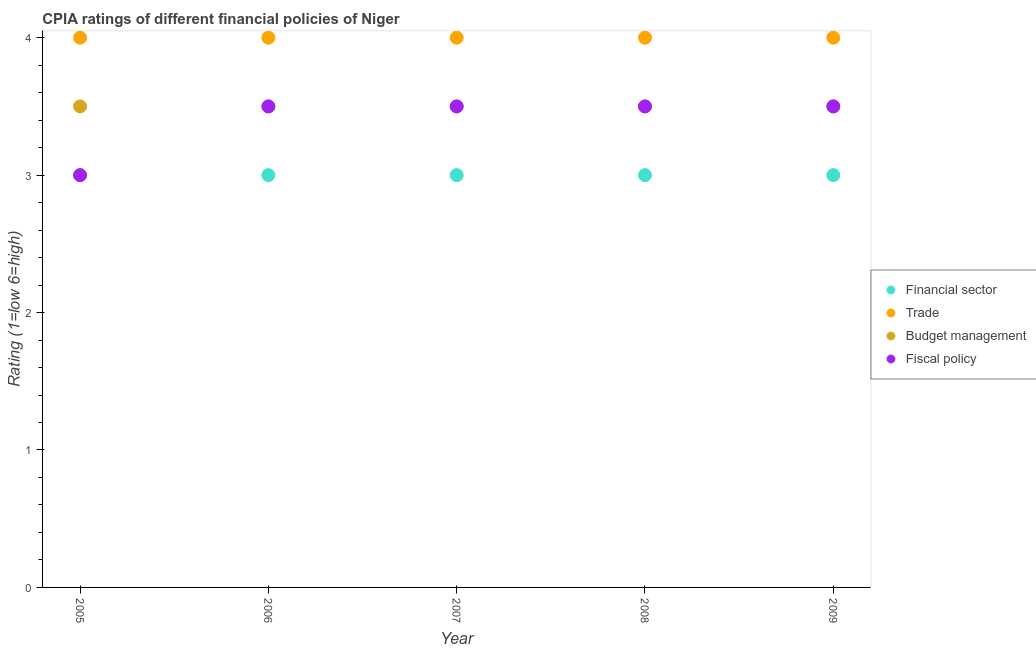Across all years, what is the maximum cpia rating of trade?
Keep it short and to the point. 4. Across all years, what is the minimum cpia rating of fiscal policy?
Your answer should be very brief. 3. What is the total cpia rating of budget management in the graph?
Offer a very short reply. 17.5. Is the cpia rating of fiscal policy in 2006 less than that in 2009?
Your answer should be compact. No. Is the difference between the cpia rating of trade in 2005 and 2006 greater than the difference between the cpia rating of financial sector in 2005 and 2006?
Your answer should be very brief. No. Is the sum of the cpia rating of fiscal policy in 2005 and 2009 greater than the maximum cpia rating of trade across all years?
Your response must be concise. Yes. Is it the case that in every year, the sum of the cpia rating of financial sector and cpia rating of trade is greater than the cpia rating of budget management?
Ensure brevity in your answer.  Yes. Is the cpia rating of trade strictly less than the cpia rating of fiscal policy over the years?
Provide a short and direct response. No. How many dotlines are there?
Your response must be concise. 4. What is the difference between two consecutive major ticks on the Y-axis?
Your response must be concise. 1. Are the values on the major ticks of Y-axis written in scientific E-notation?
Ensure brevity in your answer.  No. Does the graph contain any zero values?
Your answer should be very brief. No. Does the graph contain grids?
Give a very brief answer. No. Where does the legend appear in the graph?
Your answer should be very brief. Center right. How many legend labels are there?
Ensure brevity in your answer.  4. What is the title of the graph?
Your response must be concise. CPIA ratings of different financial policies of Niger. Does "European Union" appear as one of the legend labels in the graph?
Make the answer very short. No. What is the label or title of the X-axis?
Your answer should be compact. Year. What is the label or title of the Y-axis?
Provide a short and direct response. Rating (1=low 6=high). What is the Rating (1=low 6=high) in Trade in 2005?
Give a very brief answer. 4. What is the Rating (1=low 6=high) in Budget management in 2005?
Provide a succinct answer. 3.5. What is the Rating (1=low 6=high) of Fiscal policy in 2005?
Ensure brevity in your answer.  3. What is the Rating (1=low 6=high) of Financial sector in 2006?
Ensure brevity in your answer.  3. What is the Rating (1=low 6=high) in Fiscal policy in 2006?
Your response must be concise. 3.5. What is the Rating (1=low 6=high) in Trade in 2007?
Make the answer very short. 4. What is the Rating (1=low 6=high) in Budget management in 2007?
Keep it short and to the point. 3.5. What is the Rating (1=low 6=high) in Fiscal policy in 2007?
Your answer should be compact. 3.5. What is the Rating (1=low 6=high) in Financial sector in 2008?
Give a very brief answer. 3. What is the Rating (1=low 6=high) of Financial sector in 2009?
Offer a very short reply. 3. What is the Rating (1=low 6=high) of Trade in 2009?
Your answer should be very brief. 4. What is the Rating (1=low 6=high) in Fiscal policy in 2009?
Offer a terse response. 3.5. Across all years, what is the maximum Rating (1=low 6=high) in Financial sector?
Give a very brief answer. 3. Across all years, what is the minimum Rating (1=low 6=high) in Budget management?
Your response must be concise. 3.5. What is the total Rating (1=low 6=high) of Trade in the graph?
Give a very brief answer. 20. What is the total Rating (1=low 6=high) of Fiscal policy in the graph?
Your answer should be very brief. 17. What is the difference between the Rating (1=low 6=high) in Financial sector in 2005 and that in 2006?
Offer a very short reply. 0. What is the difference between the Rating (1=low 6=high) of Trade in 2005 and that in 2006?
Make the answer very short. 0. What is the difference between the Rating (1=low 6=high) in Budget management in 2005 and that in 2006?
Provide a short and direct response. 0. What is the difference between the Rating (1=low 6=high) in Fiscal policy in 2005 and that in 2006?
Provide a short and direct response. -0.5. What is the difference between the Rating (1=low 6=high) in Budget management in 2005 and that in 2007?
Make the answer very short. 0. What is the difference between the Rating (1=low 6=high) of Fiscal policy in 2005 and that in 2007?
Make the answer very short. -0.5. What is the difference between the Rating (1=low 6=high) of Financial sector in 2005 and that in 2008?
Give a very brief answer. 0. What is the difference between the Rating (1=low 6=high) of Trade in 2005 and that in 2008?
Ensure brevity in your answer.  0. What is the difference between the Rating (1=low 6=high) of Budget management in 2005 and that in 2008?
Provide a short and direct response. 0. What is the difference between the Rating (1=low 6=high) in Financial sector in 2005 and that in 2009?
Make the answer very short. 0. What is the difference between the Rating (1=low 6=high) of Budget management in 2005 and that in 2009?
Give a very brief answer. 0. What is the difference between the Rating (1=low 6=high) in Financial sector in 2006 and that in 2007?
Your answer should be compact. 0. What is the difference between the Rating (1=low 6=high) in Trade in 2006 and that in 2007?
Give a very brief answer. 0. What is the difference between the Rating (1=low 6=high) of Budget management in 2006 and that in 2007?
Provide a succinct answer. 0. What is the difference between the Rating (1=low 6=high) in Fiscal policy in 2006 and that in 2007?
Keep it short and to the point. 0. What is the difference between the Rating (1=low 6=high) in Budget management in 2006 and that in 2008?
Provide a succinct answer. 0. What is the difference between the Rating (1=low 6=high) of Fiscal policy in 2006 and that in 2008?
Provide a short and direct response. 0. What is the difference between the Rating (1=low 6=high) in Financial sector in 2006 and that in 2009?
Keep it short and to the point. 0. What is the difference between the Rating (1=low 6=high) of Budget management in 2006 and that in 2009?
Your answer should be very brief. 0. What is the difference between the Rating (1=low 6=high) in Fiscal policy in 2006 and that in 2009?
Offer a terse response. 0. What is the difference between the Rating (1=low 6=high) in Financial sector in 2007 and that in 2008?
Offer a very short reply. 0. What is the difference between the Rating (1=low 6=high) of Budget management in 2007 and that in 2008?
Give a very brief answer. 0. What is the difference between the Rating (1=low 6=high) of Budget management in 2007 and that in 2009?
Your answer should be compact. 0. What is the difference between the Rating (1=low 6=high) of Fiscal policy in 2007 and that in 2009?
Keep it short and to the point. 0. What is the difference between the Rating (1=low 6=high) in Financial sector in 2008 and that in 2009?
Provide a succinct answer. 0. What is the difference between the Rating (1=low 6=high) of Fiscal policy in 2008 and that in 2009?
Make the answer very short. 0. What is the difference between the Rating (1=low 6=high) in Financial sector in 2005 and the Rating (1=low 6=high) in Trade in 2006?
Ensure brevity in your answer.  -1. What is the difference between the Rating (1=low 6=high) in Financial sector in 2005 and the Rating (1=low 6=high) in Fiscal policy in 2006?
Your answer should be compact. -0.5. What is the difference between the Rating (1=low 6=high) in Trade in 2005 and the Rating (1=low 6=high) in Budget management in 2006?
Your response must be concise. 0.5. What is the difference between the Rating (1=low 6=high) in Budget management in 2005 and the Rating (1=low 6=high) in Fiscal policy in 2006?
Provide a short and direct response. 0. What is the difference between the Rating (1=low 6=high) in Financial sector in 2005 and the Rating (1=low 6=high) in Trade in 2007?
Make the answer very short. -1. What is the difference between the Rating (1=low 6=high) of Financial sector in 2005 and the Rating (1=low 6=high) of Fiscal policy in 2007?
Offer a very short reply. -0.5. What is the difference between the Rating (1=low 6=high) of Trade in 2005 and the Rating (1=low 6=high) of Fiscal policy in 2007?
Ensure brevity in your answer.  0.5. What is the difference between the Rating (1=low 6=high) in Budget management in 2005 and the Rating (1=low 6=high) in Fiscal policy in 2007?
Your response must be concise. 0. What is the difference between the Rating (1=low 6=high) of Financial sector in 2005 and the Rating (1=low 6=high) of Budget management in 2008?
Make the answer very short. -0.5. What is the difference between the Rating (1=low 6=high) in Financial sector in 2005 and the Rating (1=low 6=high) in Fiscal policy in 2008?
Provide a short and direct response. -0.5. What is the difference between the Rating (1=low 6=high) in Trade in 2005 and the Rating (1=low 6=high) in Fiscal policy in 2008?
Your response must be concise. 0.5. What is the difference between the Rating (1=low 6=high) in Financial sector in 2005 and the Rating (1=low 6=high) in Trade in 2009?
Ensure brevity in your answer.  -1. What is the difference between the Rating (1=low 6=high) of Financial sector in 2005 and the Rating (1=low 6=high) of Fiscal policy in 2009?
Provide a succinct answer. -0.5. What is the difference between the Rating (1=low 6=high) of Trade in 2005 and the Rating (1=low 6=high) of Budget management in 2009?
Provide a short and direct response. 0.5. What is the difference between the Rating (1=low 6=high) in Trade in 2005 and the Rating (1=low 6=high) in Fiscal policy in 2009?
Your answer should be compact. 0.5. What is the difference between the Rating (1=low 6=high) of Budget management in 2005 and the Rating (1=low 6=high) of Fiscal policy in 2009?
Keep it short and to the point. 0. What is the difference between the Rating (1=low 6=high) of Budget management in 2006 and the Rating (1=low 6=high) of Fiscal policy in 2007?
Your answer should be very brief. 0. What is the difference between the Rating (1=low 6=high) of Budget management in 2006 and the Rating (1=low 6=high) of Fiscal policy in 2008?
Give a very brief answer. 0. What is the difference between the Rating (1=low 6=high) in Financial sector in 2006 and the Rating (1=low 6=high) in Budget management in 2009?
Provide a succinct answer. -0.5. What is the difference between the Rating (1=low 6=high) in Trade in 2006 and the Rating (1=low 6=high) in Budget management in 2009?
Your response must be concise. 0.5. What is the difference between the Rating (1=low 6=high) of Financial sector in 2007 and the Rating (1=low 6=high) of Fiscal policy in 2008?
Give a very brief answer. -0.5. What is the difference between the Rating (1=low 6=high) of Trade in 2007 and the Rating (1=low 6=high) of Budget management in 2008?
Keep it short and to the point. 0.5. What is the difference between the Rating (1=low 6=high) in Trade in 2007 and the Rating (1=low 6=high) in Fiscal policy in 2008?
Your answer should be compact. 0.5. What is the difference between the Rating (1=low 6=high) in Budget management in 2007 and the Rating (1=low 6=high) in Fiscal policy in 2008?
Give a very brief answer. 0. What is the difference between the Rating (1=low 6=high) in Financial sector in 2007 and the Rating (1=low 6=high) in Budget management in 2009?
Ensure brevity in your answer.  -0.5. What is the difference between the Rating (1=low 6=high) in Financial sector in 2007 and the Rating (1=low 6=high) in Fiscal policy in 2009?
Offer a very short reply. -0.5. What is the difference between the Rating (1=low 6=high) in Budget management in 2007 and the Rating (1=low 6=high) in Fiscal policy in 2009?
Provide a short and direct response. 0. What is the difference between the Rating (1=low 6=high) of Financial sector in 2008 and the Rating (1=low 6=high) of Budget management in 2009?
Keep it short and to the point. -0.5. What is the difference between the Rating (1=low 6=high) in Financial sector in 2008 and the Rating (1=low 6=high) in Fiscal policy in 2009?
Give a very brief answer. -0.5. What is the difference between the Rating (1=low 6=high) of Trade in 2008 and the Rating (1=low 6=high) of Fiscal policy in 2009?
Give a very brief answer. 0.5. What is the average Rating (1=low 6=high) in Trade per year?
Your answer should be very brief. 4. In the year 2005, what is the difference between the Rating (1=low 6=high) of Financial sector and Rating (1=low 6=high) of Budget management?
Provide a succinct answer. -0.5. In the year 2005, what is the difference between the Rating (1=low 6=high) of Trade and Rating (1=low 6=high) of Budget management?
Make the answer very short. 0.5. In the year 2006, what is the difference between the Rating (1=low 6=high) of Financial sector and Rating (1=low 6=high) of Fiscal policy?
Your answer should be compact. -0.5. In the year 2007, what is the difference between the Rating (1=low 6=high) of Financial sector and Rating (1=low 6=high) of Trade?
Provide a short and direct response. -1. In the year 2007, what is the difference between the Rating (1=low 6=high) in Financial sector and Rating (1=low 6=high) in Budget management?
Provide a short and direct response. -0.5. In the year 2007, what is the difference between the Rating (1=low 6=high) of Trade and Rating (1=low 6=high) of Budget management?
Provide a succinct answer. 0.5. In the year 2007, what is the difference between the Rating (1=low 6=high) of Budget management and Rating (1=low 6=high) of Fiscal policy?
Keep it short and to the point. 0. In the year 2008, what is the difference between the Rating (1=low 6=high) in Financial sector and Rating (1=low 6=high) in Fiscal policy?
Your answer should be compact. -0.5. In the year 2008, what is the difference between the Rating (1=low 6=high) of Trade and Rating (1=low 6=high) of Budget management?
Offer a very short reply. 0.5. In the year 2008, what is the difference between the Rating (1=low 6=high) in Trade and Rating (1=low 6=high) in Fiscal policy?
Your answer should be compact. 0.5. In the year 2009, what is the difference between the Rating (1=low 6=high) in Financial sector and Rating (1=low 6=high) in Trade?
Your answer should be very brief. -1. In the year 2009, what is the difference between the Rating (1=low 6=high) in Trade and Rating (1=low 6=high) in Fiscal policy?
Keep it short and to the point. 0.5. What is the ratio of the Rating (1=low 6=high) in Financial sector in 2005 to that in 2006?
Offer a very short reply. 1. What is the ratio of the Rating (1=low 6=high) of Financial sector in 2005 to that in 2007?
Offer a very short reply. 1. What is the ratio of the Rating (1=low 6=high) in Budget management in 2005 to that in 2007?
Your answer should be compact. 1. What is the ratio of the Rating (1=low 6=high) of Fiscal policy in 2005 to that in 2007?
Your answer should be very brief. 0.86. What is the ratio of the Rating (1=low 6=high) of Trade in 2005 to that in 2008?
Offer a terse response. 1. What is the ratio of the Rating (1=low 6=high) of Budget management in 2005 to that in 2008?
Make the answer very short. 1. What is the ratio of the Rating (1=low 6=high) of Financial sector in 2005 to that in 2009?
Your answer should be very brief. 1. What is the ratio of the Rating (1=low 6=high) in Trade in 2005 to that in 2009?
Provide a short and direct response. 1. What is the ratio of the Rating (1=low 6=high) of Financial sector in 2006 to that in 2007?
Ensure brevity in your answer.  1. What is the ratio of the Rating (1=low 6=high) of Fiscal policy in 2006 to that in 2007?
Offer a terse response. 1. What is the ratio of the Rating (1=low 6=high) in Budget management in 2006 to that in 2008?
Your answer should be compact. 1. What is the ratio of the Rating (1=low 6=high) of Fiscal policy in 2006 to that in 2008?
Make the answer very short. 1. What is the ratio of the Rating (1=low 6=high) of Financial sector in 2006 to that in 2009?
Offer a very short reply. 1. What is the ratio of the Rating (1=low 6=high) of Budget management in 2006 to that in 2009?
Give a very brief answer. 1. What is the ratio of the Rating (1=low 6=high) in Fiscal policy in 2006 to that in 2009?
Provide a succinct answer. 1. What is the ratio of the Rating (1=low 6=high) of Financial sector in 2007 to that in 2009?
Keep it short and to the point. 1. What is the ratio of the Rating (1=low 6=high) in Trade in 2007 to that in 2009?
Provide a succinct answer. 1. What is the ratio of the Rating (1=low 6=high) in Budget management in 2007 to that in 2009?
Keep it short and to the point. 1. What is the ratio of the Rating (1=low 6=high) in Fiscal policy in 2007 to that in 2009?
Ensure brevity in your answer.  1. What is the ratio of the Rating (1=low 6=high) of Budget management in 2008 to that in 2009?
Provide a succinct answer. 1. What is the ratio of the Rating (1=low 6=high) in Fiscal policy in 2008 to that in 2009?
Give a very brief answer. 1. What is the difference between the highest and the second highest Rating (1=low 6=high) of Financial sector?
Provide a succinct answer. 0. What is the difference between the highest and the second highest Rating (1=low 6=high) of Budget management?
Ensure brevity in your answer.  0. 